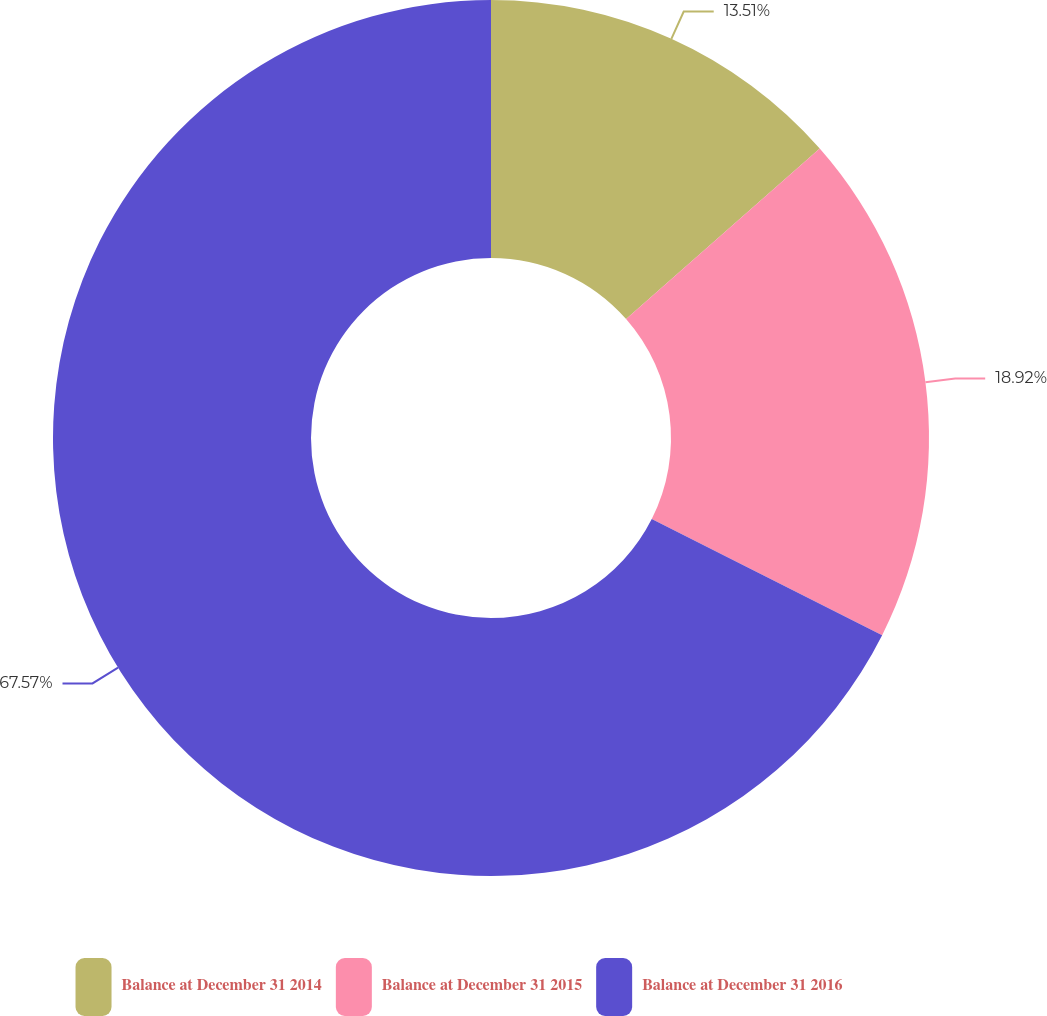Convert chart to OTSL. <chart><loc_0><loc_0><loc_500><loc_500><pie_chart><fcel>Balance at December 31 2014<fcel>Balance at December 31 2015<fcel>Balance at December 31 2016<nl><fcel>13.51%<fcel>18.92%<fcel>67.57%<nl></chart> 